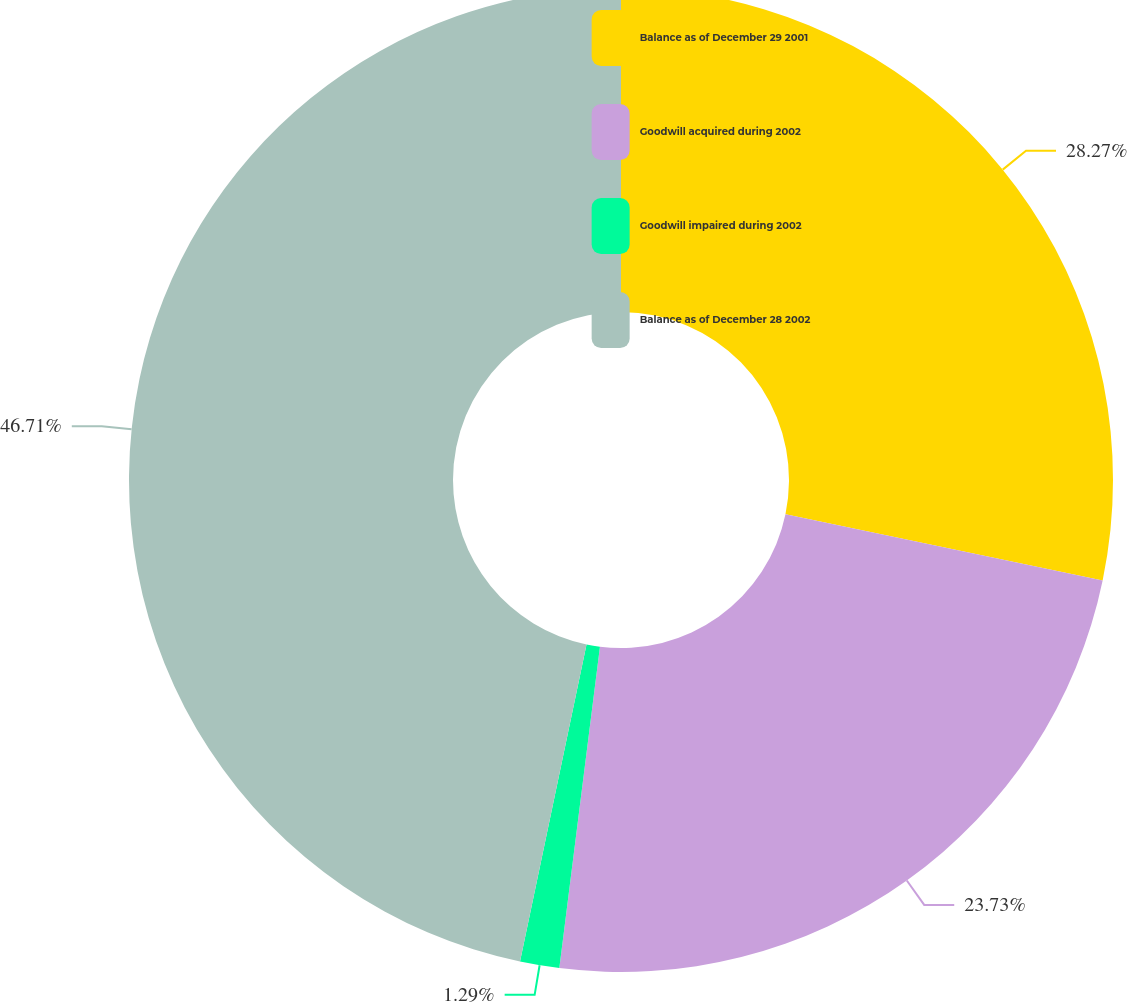Convert chart to OTSL. <chart><loc_0><loc_0><loc_500><loc_500><pie_chart><fcel>Balance as of December 29 2001<fcel>Goodwill acquired during 2002<fcel>Goodwill impaired during 2002<fcel>Balance as of December 28 2002<nl><fcel>28.27%<fcel>23.73%<fcel>1.29%<fcel>46.71%<nl></chart> 